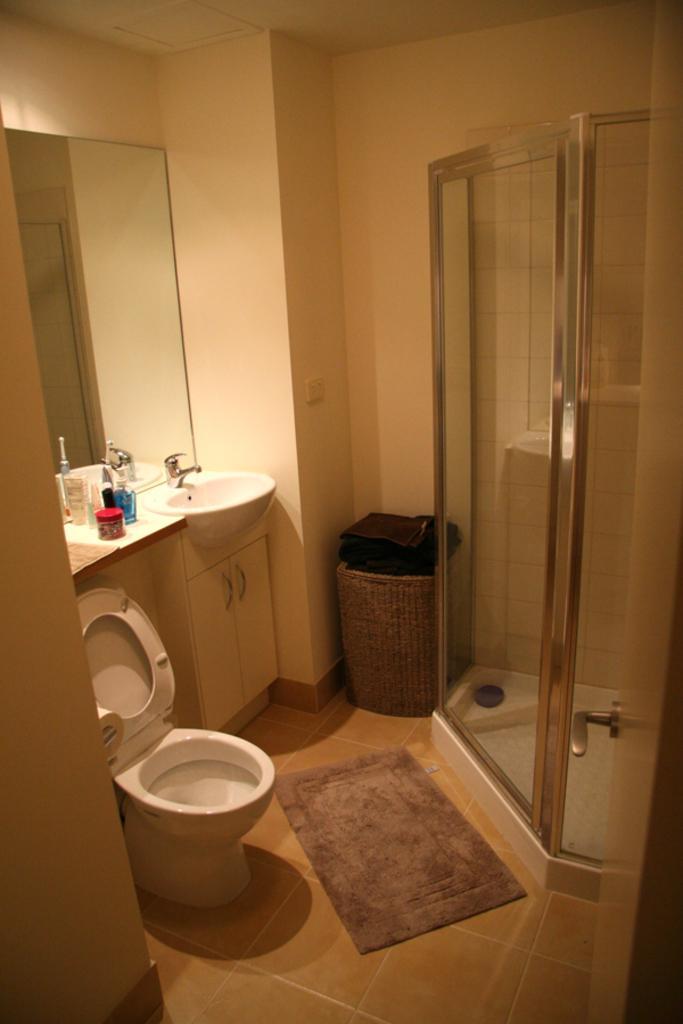Please provide a concise description of this image. In this image I can see the brown colored floor, the floor mat, a toilet seat, the sink, a tap, few bottles, a mirror attached to the wall, the ceiling, a wooden bucket and the shower. 